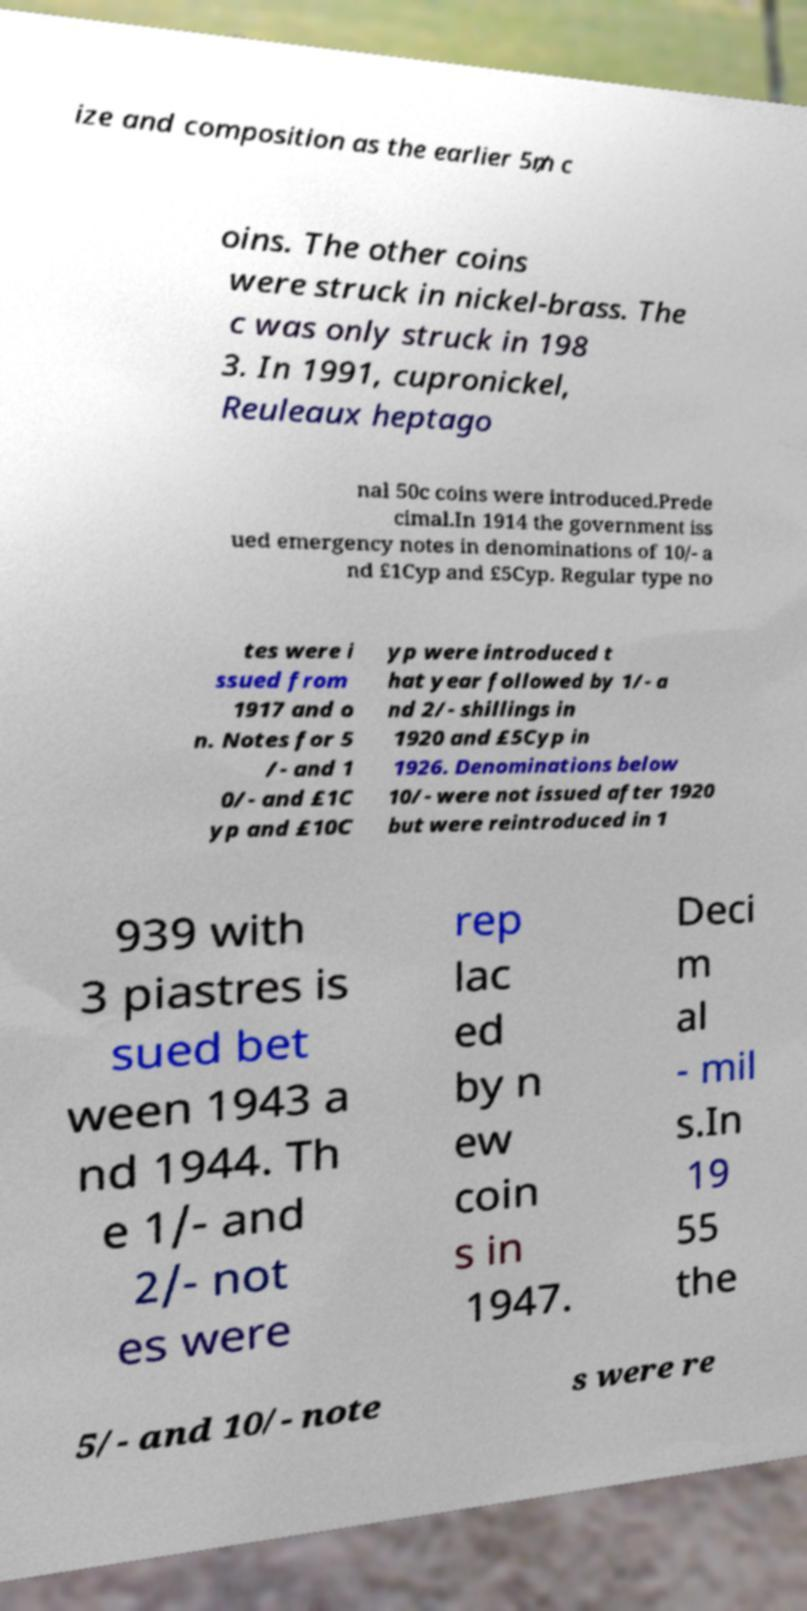For documentation purposes, I need the text within this image transcribed. Could you provide that? ize and composition as the earlier 5₥ c oins. The other coins were struck in nickel-brass. The c was only struck in 198 3. In 1991, cupronickel, Reuleaux heptago nal 50c coins were introduced.Prede cimal.In 1914 the government iss ued emergency notes in denominations of 10/- a nd £1Cyp and £5Cyp. Regular type no tes were i ssued from 1917 and o n. Notes for 5 /- and 1 0/- and £1C yp and £10C yp were introduced t hat year followed by 1/- a nd 2/- shillings in 1920 and £5Cyp in 1926. Denominations below 10/- were not issued after 1920 but were reintroduced in 1 939 with 3 piastres is sued bet ween 1943 a nd 1944. Th e 1/- and 2/- not es were rep lac ed by n ew coin s in 1947. Deci m al - mil s.In 19 55 the 5/- and 10/- note s were re 